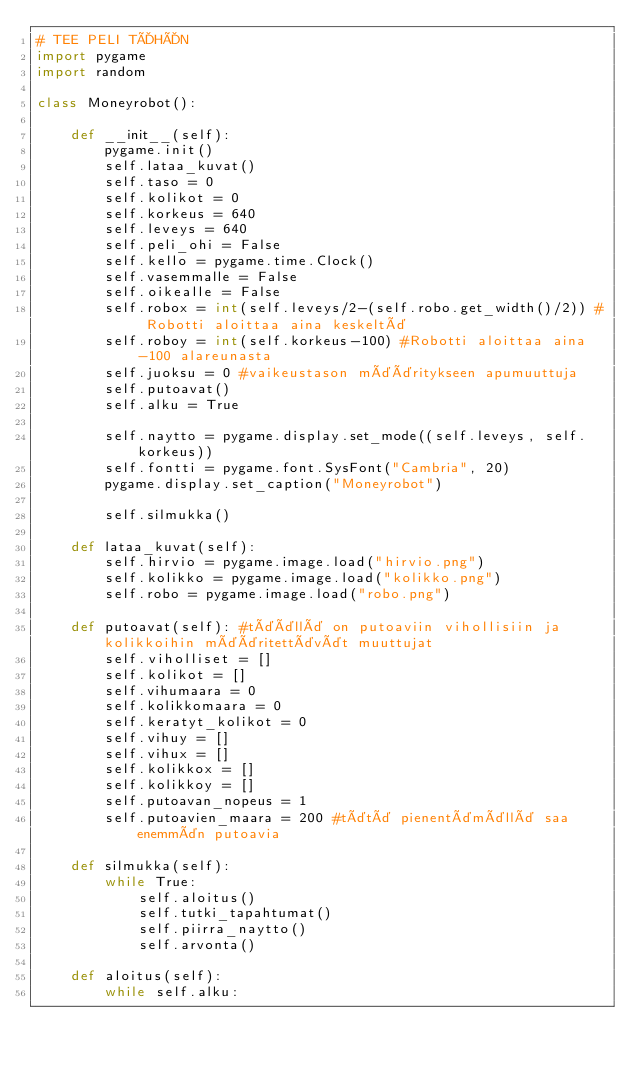<code> <loc_0><loc_0><loc_500><loc_500><_Python_># TEE PELI TÄHÄN
import pygame
import random

class Moneyrobot():

    def __init__(self):
        pygame.init()
        self.lataa_kuvat()
        self.taso = 0
        self.kolikot = 0
        self.korkeus = 640
        self.leveys = 640
        self.peli_ohi = False
        self.kello = pygame.time.Clock()
        self.vasemmalle = False
        self.oikealle = False
        self.robox = int(self.leveys/2-(self.robo.get_width()/2)) # Robotti aloittaa aina keskeltä
        self.roboy = int(self.korkeus-100) #Robotti aloittaa aina -100 alareunasta
        self.juoksu = 0 #vaikeustason määritykseen apumuuttuja
        self.putoavat()
        self.alku = True

        self.naytto = pygame.display.set_mode((self.leveys, self.korkeus))
        self.fontti = pygame.font.SysFont("Cambria", 20)
        pygame.display.set_caption("Moneyrobot")

        self.silmukka()

    def lataa_kuvat(self):
        self.hirvio = pygame.image.load("hirvio.png")
        self.kolikko = pygame.image.load("kolikko.png")
        self.robo = pygame.image.load("robo.png")

    def putoavat(self): #täällä on putoaviin vihollisiin ja kolikkoihin määritettävät muuttujat
        self.viholliset = []
        self.kolikot = []
        self.vihumaara = 0
        self.kolikkomaara = 0
        self.keratyt_kolikot = 0
        self.vihuy = []
        self.vihux = []
        self.kolikkox = []
        self.kolikkoy = []
        self.putoavan_nopeus = 1 
        self.putoavien_maara = 200 #tätä pienentämällä saa enemmän putoavia 

    def silmukka(self):
        while True:
            self.aloitus()
            self.tutki_tapahtumat()
            self.piirra_naytto()
            self.arvonta()
    
    def aloitus(self):
        while self.alku:</code> 